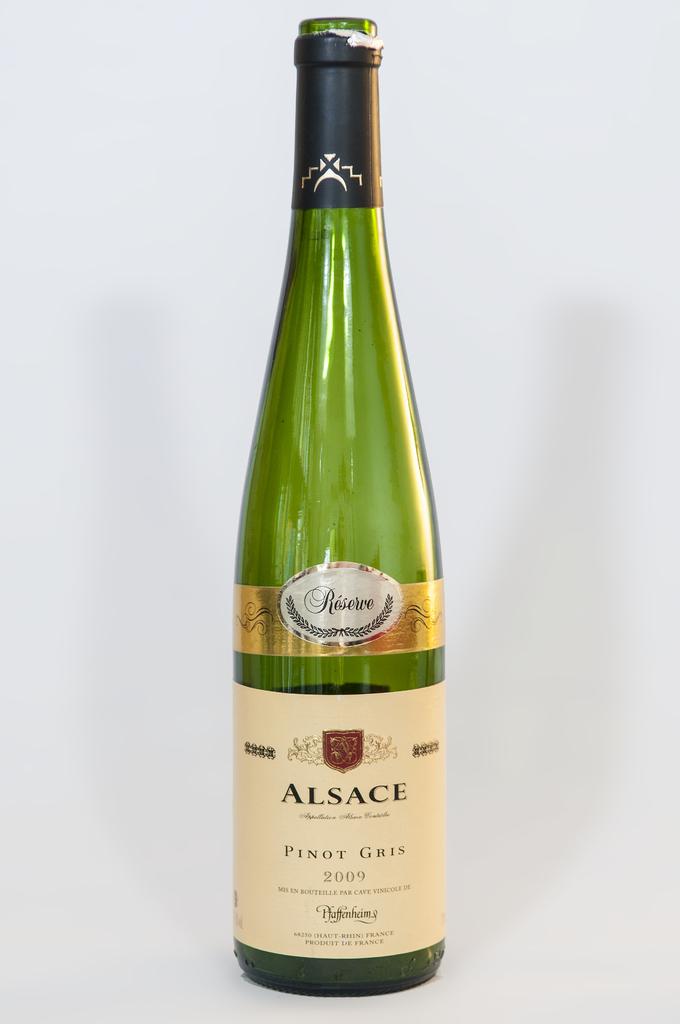What is the name of this wine?
Give a very brief answer. Alsace. What year was the wine made?
Make the answer very short. 2009. 